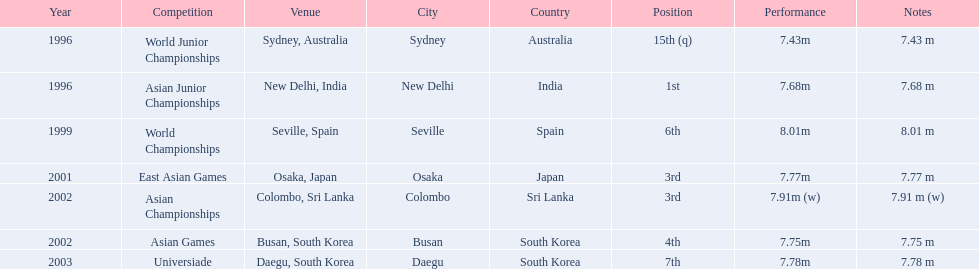What jumps did huang le make in 2002? 7.91 m (w), 7.75 m. Which jump was the longest? 7.91 m (w). 